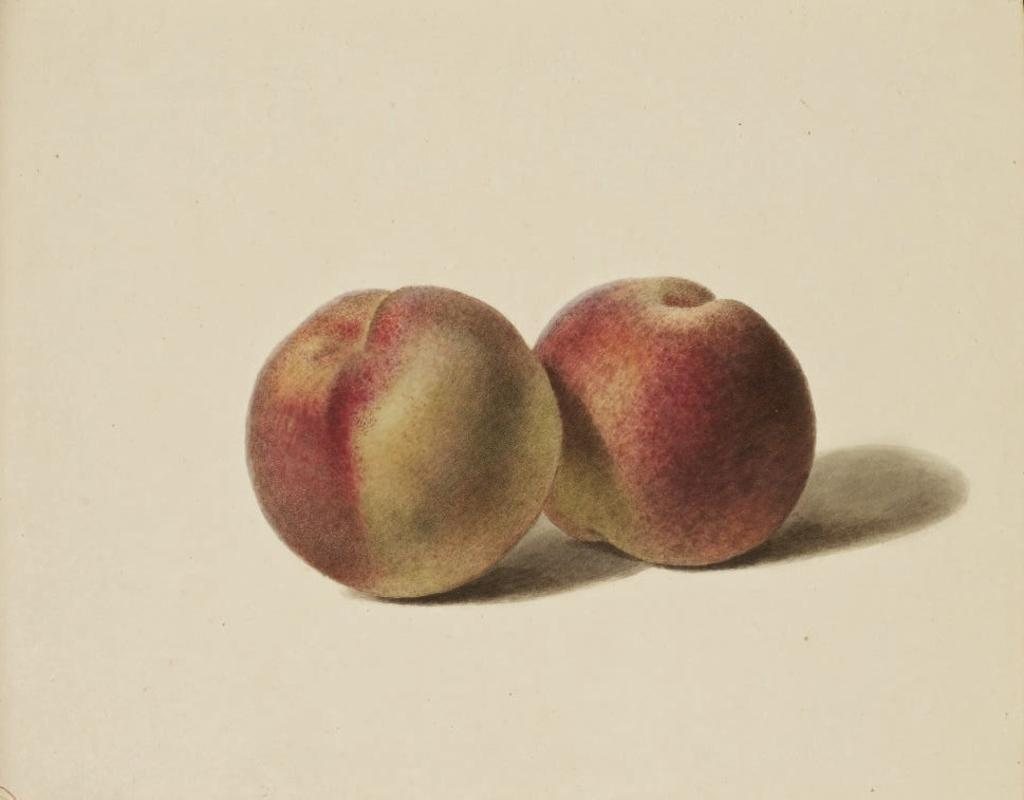What is the main subject of the image? There is a painting in the image. Where is the painting located? The painting is on a poster. What is depicted in the painting? The painting depicts two apples. What type of cloud can be seen in the painting? There is no cloud present in the painting; it depicts two apples. How many drops of water are visible on the apples in the painting? There are no drops of water visible on the apples in the painting; it only depicts two apples. 